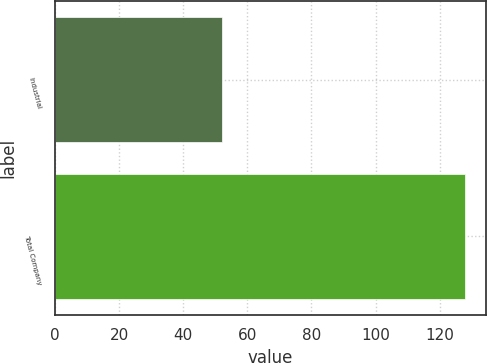<chart> <loc_0><loc_0><loc_500><loc_500><bar_chart><fcel>Industrial<fcel>Total Company<nl><fcel>52<fcel>128<nl></chart> 